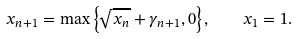Convert formula to latex. <formula><loc_0><loc_0><loc_500><loc_500>x _ { n + 1 } = \max \left \{ \sqrt { x _ { n } } + \gamma _ { n + 1 } , 0 \right \} , \quad x _ { 1 } = 1 .</formula> 